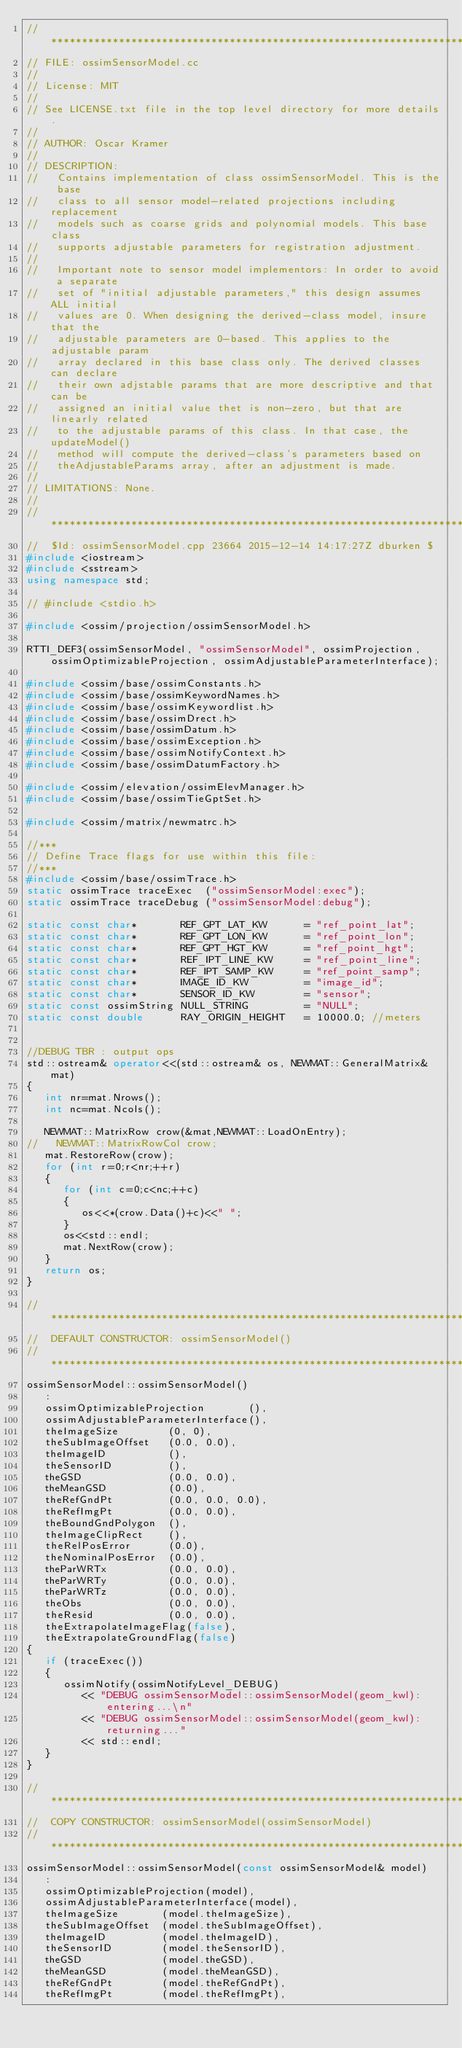Convert code to text. <code><loc_0><loc_0><loc_500><loc_500><_C++_>//*****************************************************************************
// FILE: ossimSensorModel.cc
//
// License: MIT
// 
// See LICENSE.txt file in the top level directory for more details.
//
// AUTHOR: Oscar Kramer
//
// DESCRIPTION:
//   Contains implementation of class ossimSensorModel. This is the base
//   class to all sensor model-related projections including replacement
//   models such as coarse grids and polynomial models. This base class
//   supports adjustable parameters for registration adjustment.
//
//   Important note to sensor model implementors: In order to avoid a separate
//   set of "initial adjustable parameters," this design assumes ALL initial
//   values are 0. When designing the derived-class model, insure that the
//   adjustable parameters are 0-based. This applies to the adjustable param
//   array declared in this base class only. The derived classes can declare
//   their own adjstable params that are more descriptive and that can be
//   assigned an initial value thet is non-zero, but that are linearly related
//   to the adjustable params of this class. In that case, the updateModel()
//   method will compute the derived-class's parameters based on
//   theAdjustableParams array, after an adjustment is made.
//
// LIMITATIONS: None.
//
//*****************************************************************************
//  $Id: ossimSensorModel.cpp 23664 2015-12-14 14:17:27Z dburken $
#include <iostream>
#include <sstream>
using namespace std;

// #include <stdio.h>

#include <ossim/projection/ossimSensorModel.h>

RTTI_DEF3(ossimSensorModel, "ossimSensorModel", ossimProjection, ossimOptimizableProjection, ossimAdjustableParameterInterface);

#include <ossim/base/ossimConstants.h>
#include <ossim/base/ossimKeywordNames.h>
#include <ossim/base/ossimKeywordlist.h>
#include <ossim/base/ossimDrect.h>
#include <ossim/base/ossimDatum.h>
#include <ossim/base/ossimException.h>
#include <ossim/base/ossimNotifyContext.h>
#include <ossim/base/ossimDatumFactory.h>

#include <ossim/elevation/ossimElevManager.h>
#include <ossim/base/ossimTieGptSet.h>

#include <ossim/matrix/newmatrc.h>

//***
// Define Trace flags for use within this file:
//***
#include <ossim/base/ossimTrace.h>
static ossimTrace traceExec  ("ossimSensorModel:exec");
static ossimTrace traceDebug ("ossimSensorModel:debug");

static const char*       REF_GPT_LAT_KW      = "ref_point_lat";
static const char*       REF_GPT_LON_KW      = "ref_point_lon";
static const char*       REF_GPT_HGT_KW      = "ref_point_hgt";
static const char*       REF_IPT_LINE_KW     = "ref_point_line";
static const char*       REF_IPT_SAMP_KW     = "ref_point_samp";
static const char*       IMAGE_ID_KW         = "image_id";
static const char*       SENSOR_ID_KW        = "sensor";
static const ossimString NULL_STRING         = "NULL";
static const double      RAY_ORIGIN_HEIGHT   = 10000.0; //meters


//DEBUG TBR : output ops
std::ostream& operator<<(std::ostream& os, NEWMAT::GeneralMatrix& mat)
{
   int nr=mat.Nrows();
   int nc=mat.Ncols();

   NEWMAT::MatrixRow crow(&mat,NEWMAT::LoadOnEntry);
//   NEWMAT::MatrixRowCol crow;
   mat.RestoreRow(crow);  
   for (int r=0;r<nr;++r)
   {
      for (int c=0;c<nc;++c)
      {
         os<<*(crow.Data()+c)<<" ";
      }
      os<<std::endl;
      mat.NextRow(crow);
   }
   return os;
}

//*****************************************************************************
//  DEFAULT CONSTRUCTOR: ossimSensorModel()
//*****************************************************************************
ossimSensorModel::ossimSensorModel()
   :
   ossimOptimizableProjection       (),
   ossimAdjustableParameterInterface(),
   theImageSize        (0, 0),
   theSubImageOffset   (0.0, 0.0),
   theImageID          (),
   theSensorID         (),
   theGSD              (0.0, 0.0),
   theMeanGSD          (0.0),
   theRefGndPt         (0.0, 0.0, 0.0),
   theRefImgPt         (0.0, 0.0),
   theBoundGndPolygon  (),
   theImageClipRect    (),
   theRelPosError      (0.0),
   theNominalPosError  (0.0),
   theParWRTx          (0.0, 0.0),
   theParWRTy          (0.0, 0.0),
   theParWRTz          (0.0, 0.0),
   theObs              (0.0, 0.0),
   theResid            (0.0, 0.0),
   theExtrapolateImageFlag(false),
   theExtrapolateGroundFlag(false)
{
   if (traceExec())
   {
      ossimNotify(ossimNotifyLevel_DEBUG)
         << "DEBUG ossimSensorModel::ossimSensorModel(geom_kwl): entering...\n"
         << "DEBUG ossimSensorModel::ossimSensorModel(geom_kwl): returning..."
         << std::endl;
   }
}

//*****************************************************************************
//  COPY CONSTRUCTOR: ossimSensorModel(ossimSensorModel)
//*****************************************************************************
ossimSensorModel::ossimSensorModel(const ossimSensorModel& model)
   :
   ossimOptimizableProjection(model),
   ossimAdjustableParameterInterface(model),
   theImageSize       (model.theImageSize),
   theSubImageOffset  (model.theSubImageOffset),
   theImageID         (model.theImageID),
   theSensorID        (model.theSensorID),
   theGSD             (model.theGSD),
   theMeanGSD         (model.theMeanGSD),
   theRefGndPt        (model.theRefGndPt),
   theRefImgPt        (model.theRefImgPt),</code> 